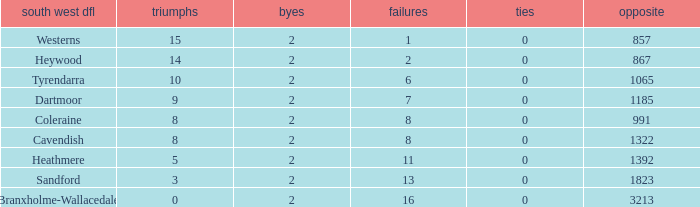How many Draws have a South West DFL of tyrendarra, and less than 10 wins? None. 